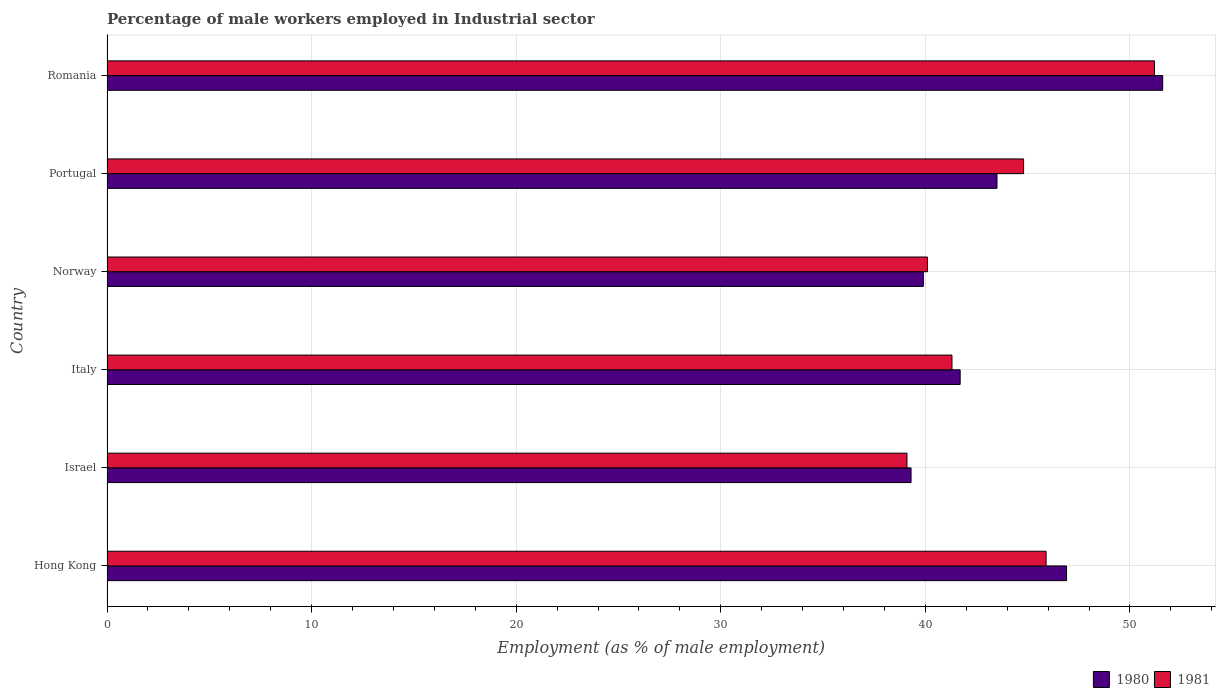Are the number of bars per tick equal to the number of legend labels?
Your answer should be very brief. Yes. Are the number of bars on each tick of the Y-axis equal?
Your answer should be very brief. Yes. How many bars are there on the 5th tick from the top?
Keep it short and to the point. 2. How many bars are there on the 6th tick from the bottom?
Make the answer very short. 2. What is the label of the 5th group of bars from the top?
Your answer should be very brief. Israel. What is the percentage of male workers employed in Industrial sector in 1981 in Portugal?
Keep it short and to the point. 44.8. Across all countries, what is the maximum percentage of male workers employed in Industrial sector in 1981?
Offer a very short reply. 51.2. Across all countries, what is the minimum percentage of male workers employed in Industrial sector in 1980?
Ensure brevity in your answer.  39.3. In which country was the percentage of male workers employed in Industrial sector in 1980 maximum?
Make the answer very short. Romania. In which country was the percentage of male workers employed in Industrial sector in 1981 minimum?
Make the answer very short. Israel. What is the total percentage of male workers employed in Industrial sector in 1981 in the graph?
Offer a very short reply. 262.4. What is the difference between the percentage of male workers employed in Industrial sector in 1981 in Norway and that in Portugal?
Provide a short and direct response. -4.7. What is the difference between the percentage of male workers employed in Industrial sector in 1981 in Romania and the percentage of male workers employed in Industrial sector in 1980 in Israel?
Keep it short and to the point. 11.9. What is the average percentage of male workers employed in Industrial sector in 1981 per country?
Keep it short and to the point. 43.73. In how many countries, is the percentage of male workers employed in Industrial sector in 1980 greater than 52 %?
Keep it short and to the point. 0. What is the ratio of the percentage of male workers employed in Industrial sector in 1981 in Hong Kong to that in Israel?
Offer a very short reply. 1.17. What is the difference between the highest and the second highest percentage of male workers employed in Industrial sector in 1981?
Your answer should be very brief. 5.3. What is the difference between the highest and the lowest percentage of male workers employed in Industrial sector in 1981?
Ensure brevity in your answer.  12.1. What does the 1st bar from the top in Norway represents?
Provide a short and direct response. 1981. How many bars are there?
Your response must be concise. 12. Are all the bars in the graph horizontal?
Your answer should be very brief. Yes. Are the values on the major ticks of X-axis written in scientific E-notation?
Keep it short and to the point. No. Does the graph contain any zero values?
Your answer should be very brief. No. Where does the legend appear in the graph?
Your answer should be compact. Bottom right. How many legend labels are there?
Offer a terse response. 2. How are the legend labels stacked?
Keep it short and to the point. Horizontal. What is the title of the graph?
Offer a terse response. Percentage of male workers employed in Industrial sector. What is the label or title of the X-axis?
Offer a very short reply. Employment (as % of male employment). What is the label or title of the Y-axis?
Your answer should be very brief. Country. What is the Employment (as % of male employment) of 1980 in Hong Kong?
Your answer should be compact. 46.9. What is the Employment (as % of male employment) in 1981 in Hong Kong?
Offer a terse response. 45.9. What is the Employment (as % of male employment) of 1980 in Israel?
Make the answer very short. 39.3. What is the Employment (as % of male employment) of 1981 in Israel?
Ensure brevity in your answer.  39.1. What is the Employment (as % of male employment) in 1980 in Italy?
Your answer should be compact. 41.7. What is the Employment (as % of male employment) in 1981 in Italy?
Offer a very short reply. 41.3. What is the Employment (as % of male employment) of 1980 in Norway?
Your response must be concise. 39.9. What is the Employment (as % of male employment) in 1981 in Norway?
Ensure brevity in your answer.  40.1. What is the Employment (as % of male employment) in 1980 in Portugal?
Your answer should be compact. 43.5. What is the Employment (as % of male employment) in 1981 in Portugal?
Make the answer very short. 44.8. What is the Employment (as % of male employment) in 1980 in Romania?
Your answer should be very brief. 51.6. What is the Employment (as % of male employment) of 1981 in Romania?
Make the answer very short. 51.2. Across all countries, what is the maximum Employment (as % of male employment) of 1980?
Give a very brief answer. 51.6. Across all countries, what is the maximum Employment (as % of male employment) in 1981?
Provide a succinct answer. 51.2. Across all countries, what is the minimum Employment (as % of male employment) of 1980?
Your answer should be very brief. 39.3. Across all countries, what is the minimum Employment (as % of male employment) of 1981?
Provide a succinct answer. 39.1. What is the total Employment (as % of male employment) in 1980 in the graph?
Your answer should be compact. 262.9. What is the total Employment (as % of male employment) in 1981 in the graph?
Provide a succinct answer. 262.4. What is the difference between the Employment (as % of male employment) of 1981 in Hong Kong and that in Italy?
Give a very brief answer. 4.6. What is the difference between the Employment (as % of male employment) of 1980 in Hong Kong and that in Norway?
Your answer should be very brief. 7. What is the difference between the Employment (as % of male employment) in 1981 in Hong Kong and that in Portugal?
Keep it short and to the point. 1.1. What is the difference between the Employment (as % of male employment) in 1980 in Israel and that in Italy?
Give a very brief answer. -2.4. What is the difference between the Employment (as % of male employment) in 1981 in Israel and that in Italy?
Give a very brief answer. -2.2. What is the difference between the Employment (as % of male employment) in 1980 in Israel and that in Norway?
Keep it short and to the point. -0.6. What is the difference between the Employment (as % of male employment) in 1980 in Israel and that in Portugal?
Make the answer very short. -4.2. What is the difference between the Employment (as % of male employment) of 1980 in Israel and that in Romania?
Offer a terse response. -12.3. What is the difference between the Employment (as % of male employment) of 1980 in Norway and that in Portugal?
Offer a very short reply. -3.6. What is the difference between the Employment (as % of male employment) in 1981 in Norway and that in Romania?
Offer a terse response. -11.1. What is the difference between the Employment (as % of male employment) of 1980 in Portugal and that in Romania?
Make the answer very short. -8.1. What is the difference between the Employment (as % of male employment) of 1981 in Portugal and that in Romania?
Offer a very short reply. -6.4. What is the difference between the Employment (as % of male employment) of 1980 in Hong Kong and the Employment (as % of male employment) of 1981 in Israel?
Your response must be concise. 7.8. What is the difference between the Employment (as % of male employment) in 1980 in Hong Kong and the Employment (as % of male employment) in 1981 in Italy?
Offer a terse response. 5.6. What is the difference between the Employment (as % of male employment) of 1980 in Hong Kong and the Employment (as % of male employment) of 1981 in Norway?
Ensure brevity in your answer.  6.8. What is the difference between the Employment (as % of male employment) of 1980 in Hong Kong and the Employment (as % of male employment) of 1981 in Portugal?
Provide a short and direct response. 2.1. What is the difference between the Employment (as % of male employment) in 1980 in Israel and the Employment (as % of male employment) in 1981 in Italy?
Provide a short and direct response. -2. What is the difference between the Employment (as % of male employment) of 1980 in Israel and the Employment (as % of male employment) of 1981 in Portugal?
Provide a short and direct response. -5.5. What is the difference between the Employment (as % of male employment) in 1980 in Israel and the Employment (as % of male employment) in 1981 in Romania?
Give a very brief answer. -11.9. What is the difference between the Employment (as % of male employment) in 1980 in Italy and the Employment (as % of male employment) in 1981 in Norway?
Your answer should be compact. 1.6. What is the average Employment (as % of male employment) in 1980 per country?
Keep it short and to the point. 43.82. What is the average Employment (as % of male employment) of 1981 per country?
Your answer should be very brief. 43.73. What is the difference between the Employment (as % of male employment) of 1980 and Employment (as % of male employment) of 1981 in Portugal?
Give a very brief answer. -1.3. What is the difference between the Employment (as % of male employment) of 1980 and Employment (as % of male employment) of 1981 in Romania?
Give a very brief answer. 0.4. What is the ratio of the Employment (as % of male employment) in 1980 in Hong Kong to that in Israel?
Your answer should be very brief. 1.19. What is the ratio of the Employment (as % of male employment) of 1981 in Hong Kong to that in Israel?
Offer a terse response. 1.17. What is the ratio of the Employment (as % of male employment) of 1980 in Hong Kong to that in Italy?
Provide a succinct answer. 1.12. What is the ratio of the Employment (as % of male employment) of 1981 in Hong Kong to that in Italy?
Give a very brief answer. 1.11. What is the ratio of the Employment (as % of male employment) of 1980 in Hong Kong to that in Norway?
Your response must be concise. 1.18. What is the ratio of the Employment (as % of male employment) of 1981 in Hong Kong to that in Norway?
Keep it short and to the point. 1.14. What is the ratio of the Employment (as % of male employment) in 1980 in Hong Kong to that in Portugal?
Make the answer very short. 1.08. What is the ratio of the Employment (as % of male employment) in 1981 in Hong Kong to that in Portugal?
Your answer should be compact. 1.02. What is the ratio of the Employment (as % of male employment) in 1980 in Hong Kong to that in Romania?
Offer a very short reply. 0.91. What is the ratio of the Employment (as % of male employment) of 1981 in Hong Kong to that in Romania?
Provide a short and direct response. 0.9. What is the ratio of the Employment (as % of male employment) in 1980 in Israel to that in Italy?
Offer a terse response. 0.94. What is the ratio of the Employment (as % of male employment) of 1981 in Israel to that in Italy?
Provide a succinct answer. 0.95. What is the ratio of the Employment (as % of male employment) of 1980 in Israel to that in Norway?
Provide a succinct answer. 0.98. What is the ratio of the Employment (as % of male employment) of 1981 in Israel to that in Norway?
Your answer should be very brief. 0.98. What is the ratio of the Employment (as % of male employment) in 1980 in Israel to that in Portugal?
Offer a terse response. 0.9. What is the ratio of the Employment (as % of male employment) in 1981 in Israel to that in Portugal?
Provide a short and direct response. 0.87. What is the ratio of the Employment (as % of male employment) in 1980 in Israel to that in Romania?
Your answer should be compact. 0.76. What is the ratio of the Employment (as % of male employment) in 1981 in Israel to that in Romania?
Give a very brief answer. 0.76. What is the ratio of the Employment (as % of male employment) of 1980 in Italy to that in Norway?
Your answer should be compact. 1.05. What is the ratio of the Employment (as % of male employment) in 1981 in Italy to that in Norway?
Your response must be concise. 1.03. What is the ratio of the Employment (as % of male employment) of 1980 in Italy to that in Portugal?
Ensure brevity in your answer.  0.96. What is the ratio of the Employment (as % of male employment) of 1981 in Italy to that in Portugal?
Offer a very short reply. 0.92. What is the ratio of the Employment (as % of male employment) in 1980 in Italy to that in Romania?
Offer a very short reply. 0.81. What is the ratio of the Employment (as % of male employment) in 1981 in Italy to that in Romania?
Give a very brief answer. 0.81. What is the ratio of the Employment (as % of male employment) in 1980 in Norway to that in Portugal?
Make the answer very short. 0.92. What is the ratio of the Employment (as % of male employment) in 1981 in Norway to that in Portugal?
Offer a very short reply. 0.9. What is the ratio of the Employment (as % of male employment) of 1980 in Norway to that in Romania?
Give a very brief answer. 0.77. What is the ratio of the Employment (as % of male employment) in 1981 in Norway to that in Romania?
Provide a short and direct response. 0.78. What is the ratio of the Employment (as % of male employment) of 1980 in Portugal to that in Romania?
Make the answer very short. 0.84. What is the ratio of the Employment (as % of male employment) in 1981 in Portugal to that in Romania?
Your answer should be very brief. 0.88. What is the difference between the highest and the second highest Employment (as % of male employment) in 1980?
Make the answer very short. 4.7. What is the difference between the highest and the second highest Employment (as % of male employment) of 1981?
Keep it short and to the point. 5.3. What is the difference between the highest and the lowest Employment (as % of male employment) in 1980?
Your answer should be compact. 12.3. 